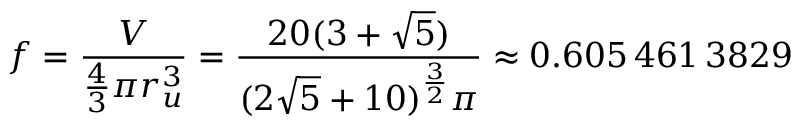Convert formula to latex. <formula><loc_0><loc_0><loc_500><loc_500>f = { \frac { V } { { \frac { 4 } { 3 } } \pi r _ { u } ^ { 3 } } } = { \frac { 2 0 ( 3 + { \sqrt { 5 } } ) } { ( 2 { \sqrt { 5 } } + 1 0 ) ^ { \frac { 3 } { 2 } } \pi } } \approx 0 . 6 0 5 \, 4 6 1 \, 3 8 2 9</formula> 